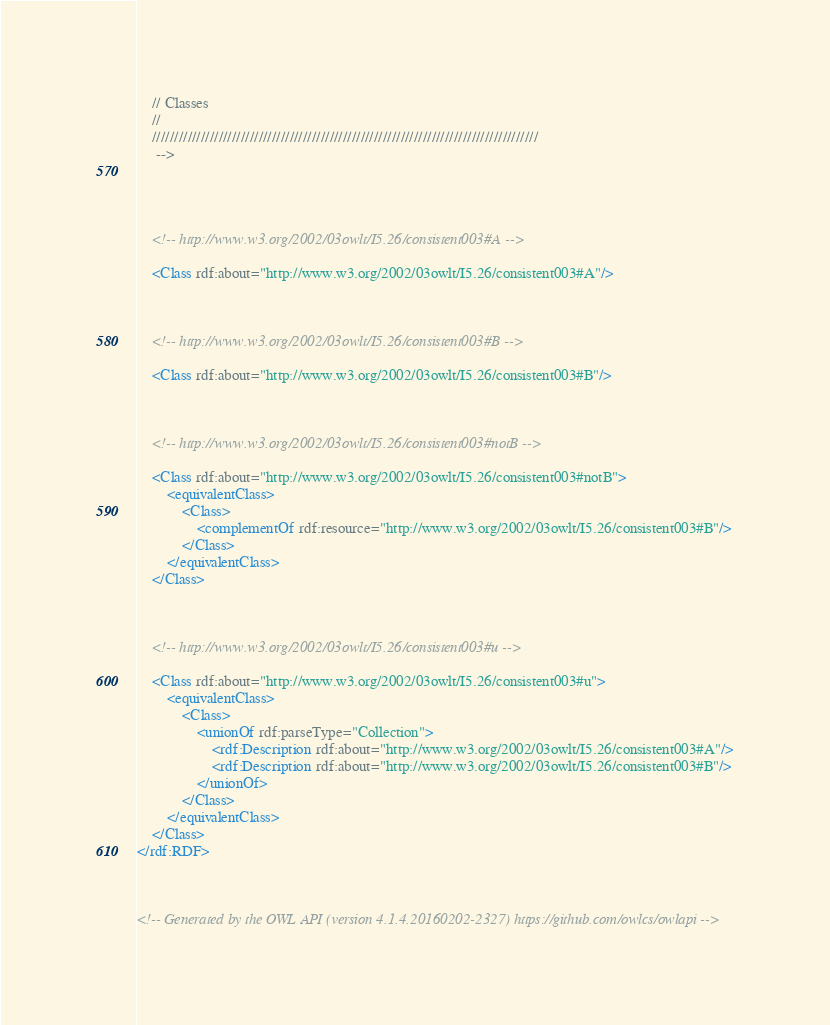<code> <loc_0><loc_0><loc_500><loc_500><_XML_>    // Classes
    //
    ///////////////////////////////////////////////////////////////////////////////////////
     -->

    


    <!-- http://www.w3.org/2002/03owlt/I5.26/consistent003#A -->

    <Class rdf:about="http://www.w3.org/2002/03owlt/I5.26/consistent003#A"/>
    


    <!-- http://www.w3.org/2002/03owlt/I5.26/consistent003#B -->

    <Class rdf:about="http://www.w3.org/2002/03owlt/I5.26/consistent003#B"/>
    


    <!-- http://www.w3.org/2002/03owlt/I5.26/consistent003#notB -->

    <Class rdf:about="http://www.w3.org/2002/03owlt/I5.26/consistent003#notB">
        <equivalentClass>
            <Class>
                <complementOf rdf:resource="http://www.w3.org/2002/03owlt/I5.26/consistent003#B"/>
            </Class>
        </equivalentClass>
    </Class>
    


    <!-- http://www.w3.org/2002/03owlt/I5.26/consistent003#u -->

    <Class rdf:about="http://www.w3.org/2002/03owlt/I5.26/consistent003#u">
        <equivalentClass>
            <Class>
                <unionOf rdf:parseType="Collection">
                    <rdf:Description rdf:about="http://www.w3.org/2002/03owlt/I5.26/consistent003#A"/>
                    <rdf:Description rdf:about="http://www.w3.org/2002/03owlt/I5.26/consistent003#B"/>
                </unionOf>
            </Class>
        </equivalentClass>
    </Class>
</rdf:RDF>



<!-- Generated by the OWL API (version 4.1.4.20160202-2327) https://github.com/owlcs/owlapi -->

</code> 